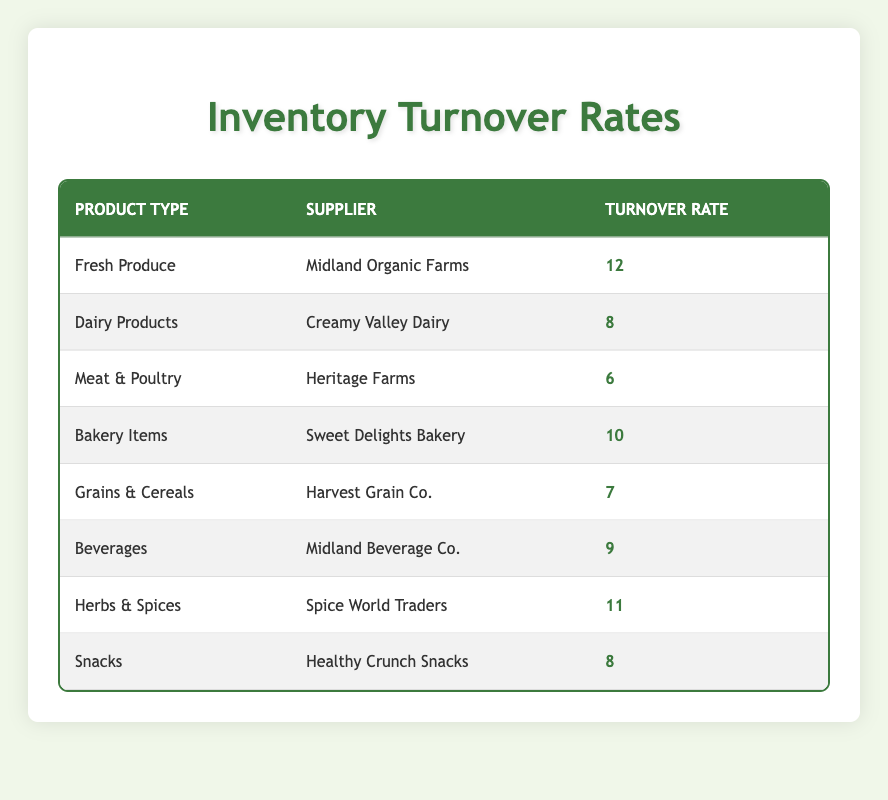What is the turnover rate for Fresh Produce? The table shows that the turnover rate for Fresh Produce, supplied by Midland Organic Farms, is 12.
Answer: 12 Which supplier has the highest turnover rate? By examining the turnover rates, Midland Organic Farms has the highest turnover rate at 12 compared to the other suppliers.
Answer: Midland Organic Farms What is the average turnover rate for Dairy Products and Snacks? First, we find the turnover rate for Dairy Products, which is 8, and for Snacks, which is also 8. Then we calculate the average: (8 + 8) / 2 = 8.
Answer: 8 Is the turnover rate for Meat & Poultry greater than that for Grains & Cereals? The turnover rate for Meat & Poultry is 6, and for Grains & Cereals, it is 7. Since 6 is not greater than 7, the answer is no.
Answer: No What is the sum of the turnover rates for Beverages and Bakery Items? The turnover rate for Beverages is 9 and for Bakery Items is 10. Adding these values gives us 9 + 10 = 19.
Answer: 19 Which product type has a turnover rate less than 8? The table indicates that Meat & Poultry has a turnover rate of 6, which is less than 8. Therefore, Meat & Poultry is the only product type that meets this criterion.
Answer: Meat & Poultry What is the difference in turnover rate between Herbs & Spices and Dairy Products? Herbs & Spices has a turnover rate of 11 and Dairy Products has a turnover rate of 8. The difference is 11 - 8 = 3.
Answer: 3 Do any suppliers have a turnover rate of 7 or higher? By checking the table, we can see that multiple suppliers, including Midland Organic Farms, Sweet Delights Bakery, Spice World Traders, and others, have turnover rates of 7 or higher. Therefore, the answer is yes.
Answer: Yes What product type has the second highest turnover rate? Analyzing the table, Fresh Produce with a turnover rate of 12 is highest, followed by Herbs & Spices with a rate of 11, making Herbs & Spices the second highest.
Answer: Herbs & Spices 